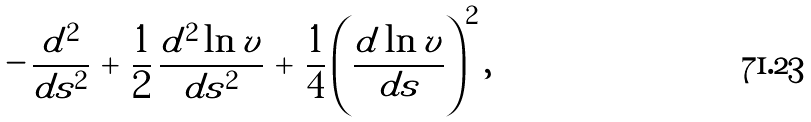Convert formula to latex. <formula><loc_0><loc_0><loc_500><loc_500>- \, \frac { d ^ { 2 } } { d s ^ { 2 } } \, + \, \frac { 1 } { 2 } \, \frac { d ^ { 2 } \ln v } { d s ^ { 2 } } \, + \, \frac { 1 } { 4 } \left ( \frac { d \ln v } { d s } \right ) ^ { 2 } ,</formula> 